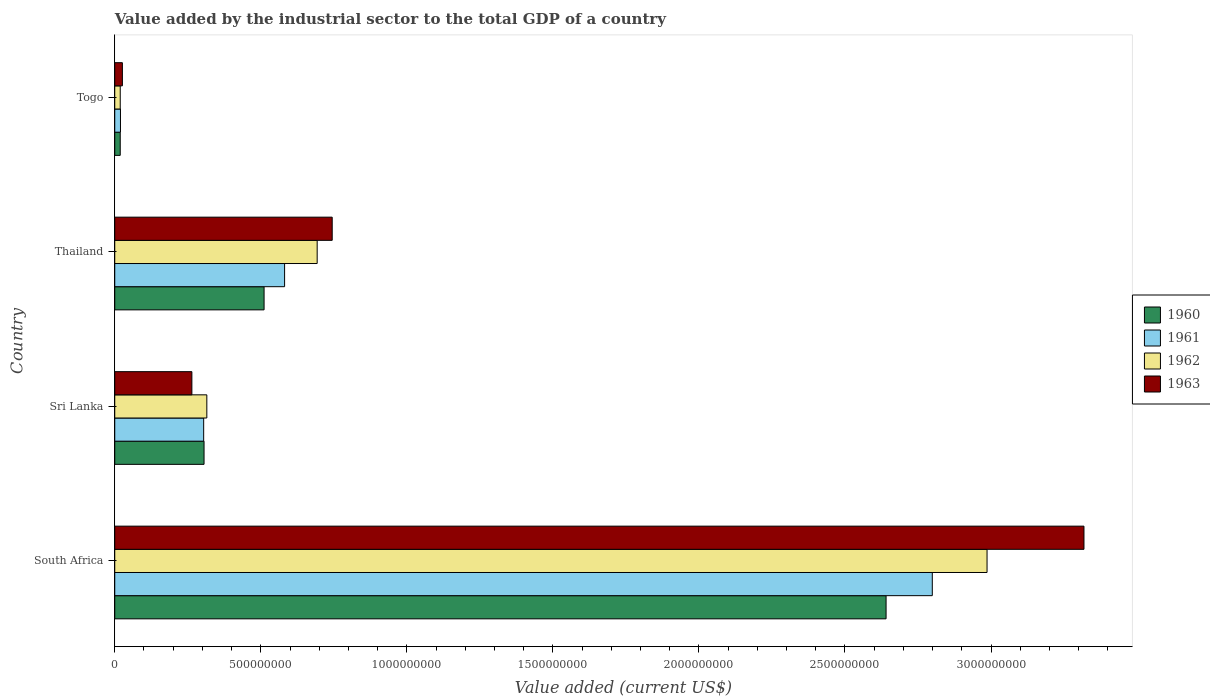How many bars are there on the 2nd tick from the top?
Offer a very short reply. 4. How many bars are there on the 3rd tick from the bottom?
Make the answer very short. 4. What is the label of the 3rd group of bars from the top?
Offer a very short reply. Sri Lanka. What is the value added by the industrial sector to the total GDP in 1960 in Togo?
Provide a short and direct response. 1.88e+07. Across all countries, what is the maximum value added by the industrial sector to the total GDP in 1962?
Your answer should be very brief. 2.99e+09. Across all countries, what is the minimum value added by the industrial sector to the total GDP in 1960?
Keep it short and to the point. 1.88e+07. In which country was the value added by the industrial sector to the total GDP in 1961 maximum?
Give a very brief answer. South Africa. In which country was the value added by the industrial sector to the total GDP in 1961 minimum?
Ensure brevity in your answer.  Togo. What is the total value added by the industrial sector to the total GDP in 1960 in the graph?
Your answer should be very brief. 3.48e+09. What is the difference between the value added by the industrial sector to the total GDP in 1963 in South Africa and that in Sri Lanka?
Your answer should be compact. 3.05e+09. What is the difference between the value added by the industrial sector to the total GDP in 1960 in Thailand and the value added by the industrial sector to the total GDP in 1961 in South Africa?
Your answer should be compact. -2.29e+09. What is the average value added by the industrial sector to the total GDP in 1963 per country?
Offer a very short reply. 1.09e+09. What is the difference between the value added by the industrial sector to the total GDP in 1963 and value added by the industrial sector to the total GDP in 1961 in Sri Lanka?
Ensure brevity in your answer.  -4.04e+07. In how many countries, is the value added by the industrial sector to the total GDP in 1960 greater than 300000000 US$?
Your answer should be compact. 3. What is the ratio of the value added by the industrial sector to the total GDP in 1962 in Sri Lanka to that in Togo?
Keep it short and to the point. 16.79. What is the difference between the highest and the second highest value added by the industrial sector to the total GDP in 1963?
Your response must be concise. 2.57e+09. What is the difference between the highest and the lowest value added by the industrial sector to the total GDP in 1962?
Provide a succinct answer. 2.97e+09. In how many countries, is the value added by the industrial sector to the total GDP in 1960 greater than the average value added by the industrial sector to the total GDP in 1960 taken over all countries?
Offer a terse response. 1. Is the sum of the value added by the industrial sector to the total GDP in 1962 in Thailand and Togo greater than the maximum value added by the industrial sector to the total GDP in 1960 across all countries?
Your answer should be compact. No. What does the 3rd bar from the top in South Africa represents?
Your answer should be compact. 1961. Is it the case that in every country, the sum of the value added by the industrial sector to the total GDP in 1961 and value added by the industrial sector to the total GDP in 1962 is greater than the value added by the industrial sector to the total GDP in 1963?
Your response must be concise. Yes. How many bars are there?
Your answer should be very brief. 16. What is the difference between two consecutive major ticks on the X-axis?
Make the answer very short. 5.00e+08. Are the values on the major ticks of X-axis written in scientific E-notation?
Provide a short and direct response. No. Does the graph contain any zero values?
Offer a very short reply. No. Where does the legend appear in the graph?
Provide a succinct answer. Center right. How are the legend labels stacked?
Your answer should be compact. Vertical. What is the title of the graph?
Provide a succinct answer. Value added by the industrial sector to the total GDP of a country. What is the label or title of the X-axis?
Make the answer very short. Value added (current US$). What is the label or title of the Y-axis?
Provide a succinct answer. Country. What is the Value added (current US$) in 1960 in South Africa?
Keep it short and to the point. 2.64e+09. What is the Value added (current US$) in 1961 in South Africa?
Keep it short and to the point. 2.80e+09. What is the Value added (current US$) in 1962 in South Africa?
Your response must be concise. 2.99e+09. What is the Value added (current US$) of 1963 in South Africa?
Offer a terse response. 3.32e+09. What is the Value added (current US$) of 1960 in Sri Lanka?
Offer a very short reply. 3.06e+08. What is the Value added (current US$) in 1961 in Sri Lanka?
Offer a very short reply. 3.04e+08. What is the Value added (current US$) of 1962 in Sri Lanka?
Offer a terse response. 3.15e+08. What is the Value added (current US$) of 1963 in Sri Lanka?
Provide a succinct answer. 2.64e+08. What is the Value added (current US$) in 1960 in Thailand?
Give a very brief answer. 5.11e+08. What is the Value added (current US$) of 1961 in Thailand?
Your answer should be compact. 5.81e+08. What is the Value added (current US$) of 1962 in Thailand?
Offer a very short reply. 6.93e+08. What is the Value added (current US$) in 1963 in Thailand?
Offer a very short reply. 7.44e+08. What is the Value added (current US$) in 1960 in Togo?
Provide a succinct answer. 1.88e+07. What is the Value added (current US$) of 1961 in Togo?
Your response must be concise. 1.96e+07. What is the Value added (current US$) in 1962 in Togo?
Provide a short and direct response. 1.88e+07. What is the Value added (current US$) in 1963 in Togo?
Ensure brevity in your answer.  2.61e+07. Across all countries, what is the maximum Value added (current US$) in 1960?
Your response must be concise. 2.64e+09. Across all countries, what is the maximum Value added (current US$) in 1961?
Offer a terse response. 2.80e+09. Across all countries, what is the maximum Value added (current US$) of 1962?
Offer a very short reply. 2.99e+09. Across all countries, what is the maximum Value added (current US$) in 1963?
Give a very brief answer. 3.32e+09. Across all countries, what is the minimum Value added (current US$) of 1960?
Your answer should be very brief. 1.88e+07. Across all countries, what is the minimum Value added (current US$) in 1961?
Offer a terse response. 1.96e+07. Across all countries, what is the minimum Value added (current US$) of 1962?
Offer a very short reply. 1.88e+07. Across all countries, what is the minimum Value added (current US$) in 1963?
Your response must be concise. 2.61e+07. What is the total Value added (current US$) of 1960 in the graph?
Ensure brevity in your answer.  3.48e+09. What is the total Value added (current US$) in 1961 in the graph?
Make the answer very short. 3.70e+09. What is the total Value added (current US$) of 1962 in the graph?
Provide a succinct answer. 4.01e+09. What is the total Value added (current US$) of 1963 in the graph?
Offer a terse response. 4.35e+09. What is the difference between the Value added (current US$) in 1960 in South Africa and that in Sri Lanka?
Make the answer very short. 2.33e+09. What is the difference between the Value added (current US$) of 1961 in South Africa and that in Sri Lanka?
Ensure brevity in your answer.  2.49e+09. What is the difference between the Value added (current US$) in 1962 in South Africa and that in Sri Lanka?
Your response must be concise. 2.67e+09. What is the difference between the Value added (current US$) of 1963 in South Africa and that in Sri Lanka?
Offer a very short reply. 3.05e+09. What is the difference between the Value added (current US$) in 1960 in South Africa and that in Thailand?
Your response must be concise. 2.13e+09. What is the difference between the Value added (current US$) in 1961 in South Africa and that in Thailand?
Offer a terse response. 2.22e+09. What is the difference between the Value added (current US$) in 1962 in South Africa and that in Thailand?
Offer a terse response. 2.29e+09. What is the difference between the Value added (current US$) in 1963 in South Africa and that in Thailand?
Keep it short and to the point. 2.57e+09. What is the difference between the Value added (current US$) of 1960 in South Africa and that in Togo?
Your answer should be compact. 2.62e+09. What is the difference between the Value added (current US$) of 1961 in South Africa and that in Togo?
Ensure brevity in your answer.  2.78e+09. What is the difference between the Value added (current US$) in 1962 in South Africa and that in Togo?
Offer a terse response. 2.97e+09. What is the difference between the Value added (current US$) in 1963 in South Africa and that in Togo?
Your response must be concise. 3.29e+09. What is the difference between the Value added (current US$) of 1960 in Sri Lanka and that in Thailand?
Provide a succinct answer. -2.06e+08. What is the difference between the Value added (current US$) in 1961 in Sri Lanka and that in Thailand?
Offer a very short reply. -2.77e+08. What is the difference between the Value added (current US$) of 1962 in Sri Lanka and that in Thailand?
Offer a very short reply. -3.78e+08. What is the difference between the Value added (current US$) in 1963 in Sri Lanka and that in Thailand?
Offer a very short reply. -4.80e+08. What is the difference between the Value added (current US$) of 1960 in Sri Lanka and that in Togo?
Provide a short and direct response. 2.87e+08. What is the difference between the Value added (current US$) of 1961 in Sri Lanka and that in Togo?
Ensure brevity in your answer.  2.85e+08. What is the difference between the Value added (current US$) in 1962 in Sri Lanka and that in Togo?
Make the answer very short. 2.96e+08. What is the difference between the Value added (current US$) in 1963 in Sri Lanka and that in Togo?
Offer a terse response. 2.38e+08. What is the difference between the Value added (current US$) of 1960 in Thailand and that in Togo?
Your answer should be compact. 4.92e+08. What is the difference between the Value added (current US$) of 1961 in Thailand and that in Togo?
Your response must be concise. 5.62e+08. What is the difference between the Value added (current US$) in 1962 in Thailand and that in Togo?
Make the answer very short. 6.74e+08. What is the difference between the Value added (current US$) in 1963 in Thailand and that in Togo?
Give a very brief answer. 7.18e+08. What is the difference between the Value added (current US$) of 1960 in South Africa and the Value added (current US$) of 1961 in Sri Lanka?
Ensure brevity in your answer.  2.34e+09. What is the difference between the Value added (current US$) of 1960 in South Africa and the Value added (current US$) of 1962 in Sri Lanka?
Your answer should be very brief. 2.33e+09. What is the difference between the Value added (current US$) in 1960 in South Africa and the Value added (current US$) in 1963 in Sri Lanka?
Make the answer very short. 2.38e+09. What is the difference between the Value added (current US$) in 1961 in South Africa and the Value added (current US$) in 1962 in Sri Lanka?
Keep it short and to the point. 2.48e+09. What is the difference between the Value added (current US$) in 1961 in South Africa and the Value added (current US$) in 1963 in Sri Lanka?
Your answer should be very brief. 2.53e+09. What is the difference between the Value added (current US$) of 1962 in South Africa and the Value added (current US$) of 1963 in Sri Lanka?
Your answer should be very brief. 2.72e+09. What is the difference between the Value added (current US$) of 1960 in South Africa and the Value added (current US$) of 1961 in Thailand?
Keep it short and to the point. 2.06e+09. What is the difference between the Value added (current US$) in 1960 in South Africa and the Value added (current US$) in 1962 in Thailand?
Make the answer very short. 1.95e+09. What is the difference between the Value added (current US$) in 1960 in South Africa and the Value added (current US$) in 1963 in Thailand?
Ensure brevity in your answer.  1.90e+09. What is the difference between the Value added (current US$) in 1961 in South Africa and the Value added (current US$) in 1962 in Thailand?
Your answer should be compact. 2.11e+09. What is the difference between the Value added (current US$) in 1961 in South Africa and the Value added (current US$) in 1963 in Thailand?
Give a very brief answer. 2.05e+09. What is the difference between the Value added (current US$) in 1962 in South Africa and the Value added (current US$) in 1963 in Thailand?
Give a very brief answer. 2.24e+09. What is the difference between the Value added (current US$) of 1960 in South Africa and the Value added (current US$) of 1961 in Togo?
Keep it short and to the point. 2.62e+09. What is the difference between the Value added (current US$) in 1960 in South Africa and the Value added (current US$) in 1962 in Togo?
Make the answer very short. 2.62e+09. What is the difference between the Value added (current US$) of 1960 in South Africa and the Value added (current US$) of 1963 in Togo?
Make the answer very short. 2.61e+09. What is the difference between the Value added (current US$) in 1961 in South Africa and the Value added (current US$) in 1962 in Togo?
Offer a very short reply. 2.78e+09. What is the difference between the Value added (current US$) of 1961 in South Africa and the Value added (current US$) of 1963 in Togo?
Provide a succinct answer. 2.77e+09. What is the difference between the Value added (current US$) in 1962 in South Africa and the Value added (current US$) in 1963 in Togo?
Provide a succinct answer. 2.96e+09. What is the difference between the Value added (current US$) in 1960 in Sri Lanka and the Value added (current US$) in 1961 in Thailand?
Offer a terse response. -2.76e+08. What is the difference between the Value added (current US$) in 1960 in Sri Lanka and the Value added (current US$) in 1962 in Thailand?
Your response must be concise. -3.87e+08. What is the difference between the Value added (current US$) in 1960 in Sri Lanka and the Value added (current US$) in 1963 in Thailand?
Provide a short and direct response. -4.39e+08. What is the difference between the Value added (current US$) of 1961 in Sri Lanka and the Value added (current US$) of 1962 in Thailand?
Your answer should be very brief. -3.89e+08. What is the difference between the Value added (current US$) of 1961 in Sri Lanka and the Value added (current US$) of 1963 in Thailand?
Offer a terse response. -4.40e+08. What is the difference between the Value added (current US$) of 1962 in Sri Lanka and the Value added (current US$) of 1963 in Thailand?
Your response must be concise. -4.29e+08. What is the difference between the Value added (current US$) in 1960 in Sri Lanka and the Value added (current US$) in 1961 in Togo?
Ensure brevity in your answer.  2.86e+08. What is the difference between the Value added (current US$) of 1960 in Sri Lanka and the Value added (current US$) of 1962 in Togo?
Provide a succinct answer. 2.87e+08. What is the difference between the Value added (current US$) of 1960 in Sri Lanka and the Value added (current US$) of 1963 in Togo?
Your answer should be compact. 2.80e+08. What is the difference between the Value added (current US$) in 1961 in Sri Lanka and the Value added (current US$) in 1962 in Togo?
Ensure brevity in your answer.  2.86e+08. What is the difference between the Value added (current US$) in 1961 in Sri Lanka and the Value added (current US$) in 1963 in Togo?
Offer a very short reply. 2.78e+08. What is the difference between the Value added (current US$) of 1962 in Sri Lanka and the Value added (current US$) of 1963 in Togo?
Keep it short and to the point. 2.89e+08. What is the difference between the Value added (current US$) of 1960 in Thailand and the Value added (current US$) of 1961 in Togo?
Offer a very short reply. 4.92e+08. What is the difference between the Value added (current US$) of 1960 in Thailand and the Value added (current US$) of 1962 in Togo?
Keep it short and to the point. 4.92e+08. What is the difference between the Value added (current US$) in 1960 in Thailand and the Value added (current US$) in 1963 in Togo?
Your response must be concise. 4.85e+08. What is the difference between the Value added (current US$) in 1961 in Thailand and the Value added (current US$) in 1962 in Togo?
Offer a very short reply. 5.63e+08. What is the difference between the Value added (current US$) of 1961 in Thailand and the Value added (current US$) of 1963 in Togo?
Offer a terse response. 5.55e+08. What is the difference between the Value added (current US$) of 1962 in Thailand and the Value added (current US$) of 1963 in Togo?
Ensure brevity in your answer.  6.67e+08. What is the average Value added (current US$) in 1960 per country?
Your answer should be compact. 8.69e+08. What is the average Value added (current US$) in 1961 per country?
Give a very brief answer. 9.26e+08. What is the average Value added (current US$) of 1962 per country?
Provide a succinct answer. 1.00e+09. What is the average Value added (current US$) in 1963 per country?
Your answer should be compact. 1.09e+09. What is the difference between the Value added (current US$) in 1960 and Value added (current US$) in 1961 in South Africa?
Offer a very short reply. -1.58e+08. What is the difference between the Value added (current US$) in 1960 and Value added (current US$) in 1962 in South Africa?
Your answer should be very brief. -3.46e+08. What is the difference between the Value added (current US$) of 1960 and Value added (current US$) of 1963 in South Africa?
Ensure brevity in your answer.  -6.78e+08. What is the difference between the Value added (current US$) of 1961 and Value added (current US$) of 1962 in South Africa?
Keep it short and to the point. -1.87e+08. What is the difference between the Value added (current US$) in 1961 and Value added (current US$) in 1963 in South Africa?
Your response must be concise. -5.19e+08. What is the difference between the Value added (current US$) of 1962 and Value added (current US$) of 1963 in South Africa?
Keep it short and to the point. -3.32e+08. What is the difference between the Value added (current US$) of 1960 and Value added (current US$) of 1961 in Sri Lanka?
Provide a succinct answer. 1.26e+06. What is the difference between the Value added (current US$) in 1960 and Value added (current US$) in 1962 in Sri Lanka?
Provide a short and direct response. -9.55e+06. What is the difference between the Value added (current US$) in 1960 and Value added (current US$) in 1963 in Sri Lanka?
Provide a short and direct response. 4.16e+07. What is the difference between the Value added (current US$) in 1961 and Value added (current US$) in 1962 in Sri Lanka?
Your answer should be compact. -1.08e+07. What is the difference between the Value added (current US$) of 1961 and Value added (current US$) of 1963 in Sri Lanka?
Make the answer very short. 4.04e+07. What is the difference between the Value added (current US$) in 1962 and Value added (current US$) in 1963 in Sri Lanka?
Your response must be concise. 5.12e+07. What is the difference between the Value added (current US$) of 1960 and Value added (current US$) of 1961 in Thailand?
Your answer should be compact. -7.03e+07. What is the difference between the Value added (current US$) in 1960 and Value added (current US$) in 1962 in Thailand?
Offer a very short reply. -1.82e+08. What is the difference between the Value added (current US$) in 1960 and Value added (current US$) in 1963 in Thailand?
Keep it short and to the point. -2.33e+08. What is the difference between the Value added (current US$) in 1961 and Value added (current US$) in 1962 in Thailand?
Give a very brief answer. -1.12e+08. What is the difference between the Value added (current US$) in 1961 and Value added (current US$) in 1963 in Thailand?
Offer a very short reply. -1.63e+08. What is the difference between the Value added (current US$) of 1962 and Value added (current US$) of 1963 in Thailand?
Give a very brief answer. -5.15e+07. What is the difference between the Value added (current US$) of 1960 and Value added (current US$) of 1961 in Togo?
Provide a succinct answer. -8.10e+05. What is the difference between the Value added (current US$) in 1960 and Value added (current US$) in 1962 in Togo?
Keep it short and to the point. -1.39e+04. What is the difference between the Value added (current US$) in 1960 and Value added (current US$) in 1963 in Togo?
Offer a terse response. -7.36e+06. What is the difference between the Value added (current US$) in 1961 and Value added (current US$) in 1962 in Togo?
Your response must be concise. 7.97e+05. What is the difference between the Value added (current US$) in 1961 and Value added (current US$) in 1963 in Togo?
Ensure brevity in your answer.  -6.55e+06. What is the difference between the Value added (current US$) of 1962 and Value added (current US$) of 1963 in Togo?
Your response must be concise. -7.35e+06. What is the ratio of the Value added (current US$) in 1960 in South Africa to that in Sri Lanka?
Keep it short and to the point. 8.64. What is the ratio of the Value added (current US$) in 1961 in South Africa to that in Sri Lanka?
Your response must be concise. 9.19. What is the ratio of the Value added (current US$) in 1962 in South Africa to that in Sri Lanka?
Your answer should be compact. 9.47. What is the ratio of the Value added (current US$) of 1963 in South Africa to that in Sri Lanka?
Provide a short and direct response. 12.57. What is the ratio of the Value added (current US$) of 1960 in South Africa to that in Thailand?
Your answer should be compact. 5.17. What is the ratio of the Value added (current US$) of 1961 in South Africa to that in Thailand?
Your answer should be compact. 4.81. What is the ratio of the Value added (current US$) of 1962 in South Africa to that in Thailand?
Provide a short and direct response. 4.31. What is the ratio of the Value added (current US$) of 1963 in South Africa to that in Thailand?
Offer a very short reply. 4.46. What is the ratio of the Value added (current US$) of 1960 in South Africa to that in Togo?
Give a very brief answer. 140.76. What is the ratio of the Value added (current US$) in 1961 in South Africa to that in Togo?
Your response must be concise. 143.01. What is the ratio of the Value added (current US$) of 1962 in South Africa to that in Togo?
Provide a succinct answer. 159.06. What is the ratio of the Value added (current US$) of 1963 in South Africa to that in Togo?
Your response must be concise. 127.03. What is the ratio of the Value added (current US$) of 1960 in Sri Lanka to that in Thailand?
Keep it short and to the point. 0.6. What is the ratio of the Value added (current US$) of 1961 in Sri Lanka to that in Thailand?
Provide a short and direct response. 0.52. What is the ratio of the Value added (current US$) of 1962 in Sri Lanka to that in Thailand?
Provide a succinct answer. 0.45. What is the ratio of the Value added (current US$) of 1963 in Sri Lanka to that in Thailand?
Provide a short and direct response. 0.35. What is the ratio of the Value added (current US$) of 1960 in Sri Lanka to that in Togo?
Provide a succinct answer. 16.29. What is the ratio of the Value added (current US$) in 1961 in Sri Lanka to that in Togo?
Give a very brief answer. 15.55. What is the ratio of the Value added (current US$) of 1962 in Sri Lanka to that in Togo?
Provide a succinct answer. 16.79. What is the ratio of the Value added (current US$) in 1963 in Sri Lanka to that in Togo?
Offer a very short reply. 10.11. What is the ratio of the Value added (current US$) in 1960 in Thailand to that in Togo?
Give a very brief answer. 27.25. What is the ratio of the Value added (current US$) in 1961 in Thailand to that in Togo?
Keep it short and to the point. 29.71. What is the ratio of the Value added (current US$) of 1962 in Thailand to that in Togo?
Give a very brief answer. 36.91. What is the difference between the highest and the second highest Value added (current US$) of 1960?
Your answer should be very brief. 2.13e+09. What is the difference between the highest and the second highest Value added (current US$) in 1961?
Your answer should be very brief. 2.22e+09. What is the difference between the highest and the second highest Value added (current US$) of 1962?
Provide a short and direct response. 2.29e+09. What is the difference between the highest and the second highest Value added (current US$) of 1963?
Provide a short and direct response. 2.57e+09. What is the difference between the highest and the lowest Value added (current US$) of 1960?
Give a very brief answer. 2.62e+09. What is the difference between the highest and the lowest Value added (current US$) in 1961?
Give a very brief answer. 2.78e+09. What is the difference between the highest and the lowest Value added (current US$) in 1962?
Give a very brief answer. 2.97e+09. What is the difference between the highest and the lowest Value added (current US$) in 1963?
Your answer should be compact. 3.29e+09. 